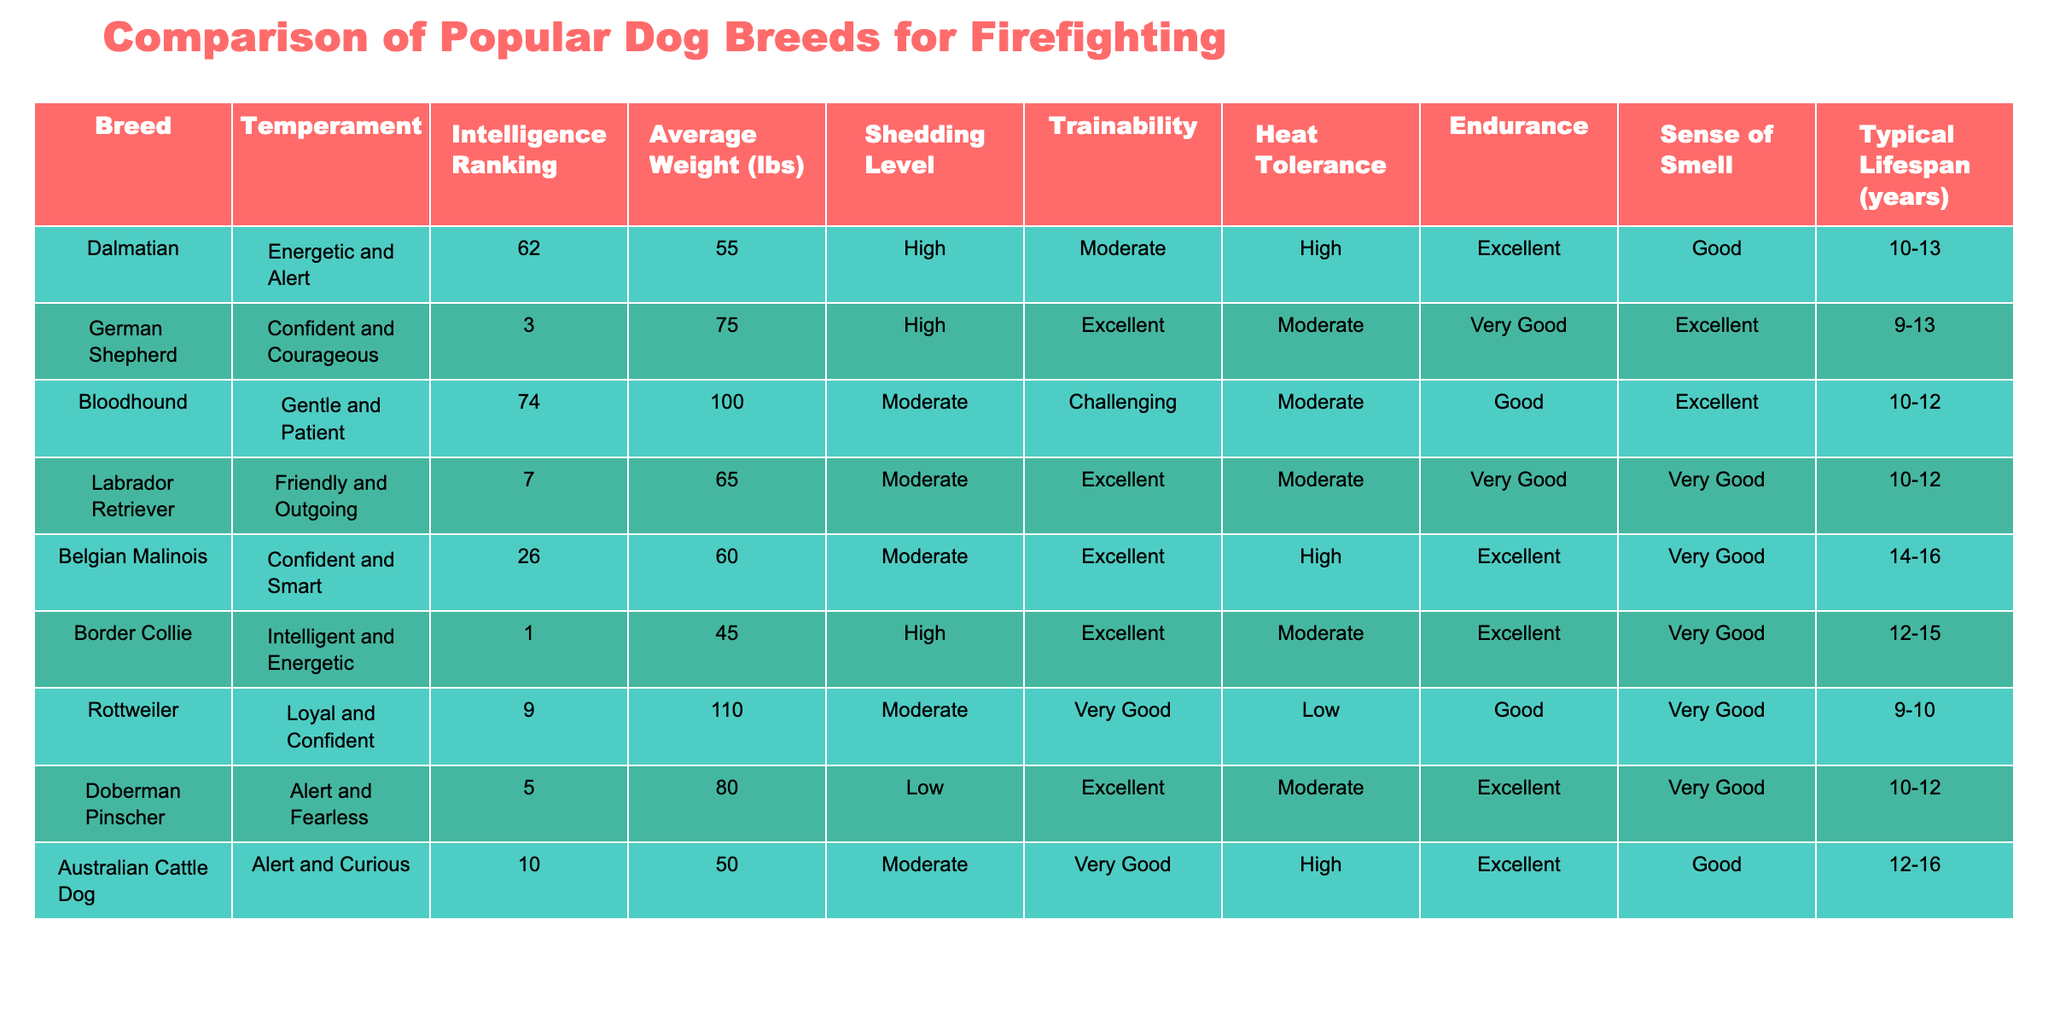What is the average weight of the Dalmatian? The table lists the Dalmatian's weight as 55 lbs. Since the question only pertains to this specific breed, no calculations are needed.
Answer: 55 lbs Which dog breed has the highest intelligence ranking? Referring to the table, the Border Collie has an intelligence ranking of 1, which is the highest among all the listed breeds.
Answer: Border Collie Is the Labrador Retriever known for high shedding levels? According to the table, the shedding level of the Labrador Retriever is described as moderate, which means it does not have a high shedding level.
Answer: No What is the average lifespan of the German Shepherd? The table shows that the typical lifespan of the German Shepherd is between 9 to 13 years. Since this is a range, the average can be calculated by taking the midpoint: (9 + 13) / 2 = 11 years.
Answer: 11 years How many breeds have excellent trainability? Looking at the trainability column, the breeds identified with "Excellent" trainability are German Shepherd, Labrador Retriever, Belgian Malinois, and Doberman Pinscher. This gives a total of 4 breeds with excellent trainability.
Answer: 4 breeds What is the difference in average weight between the Rottweiler and the Australian Cattle Dog? The table shows the Rottweiler's weight as 110 lbs and the Australian Cattle Dog's weight as 50 lbs. To find the difference, we subtract: 110 - 50 = 60 lbs.
Answer: 60 lbs Which dog breed has both high heat tolerance and endurance? Referring to the table, both the Dalmatian and the Belgian Malinois have high heat tolerance and excellent endurance, making them suitable in these categories.
Answer: Dalmatian and Belgian Malinois Is the Bloodhound the largest breed in terms of average weight? The table indicates that the Bloodhound has an average weight of 100 lbs, and checking the weights of other breeds reveals that the Rottweiler is heavier at 110 lbs. Thus, the Bloodhound is not the largest breed by weight.
Answer: No What breed has the longest typical lifespan and what is it? The table shows that the Belgian Malinois has the longest typical lifespan, ranging between 14 to 16 years. To find the average, we calculate (14 + 16) / 2 = 15 years.
Answer: 15 years 